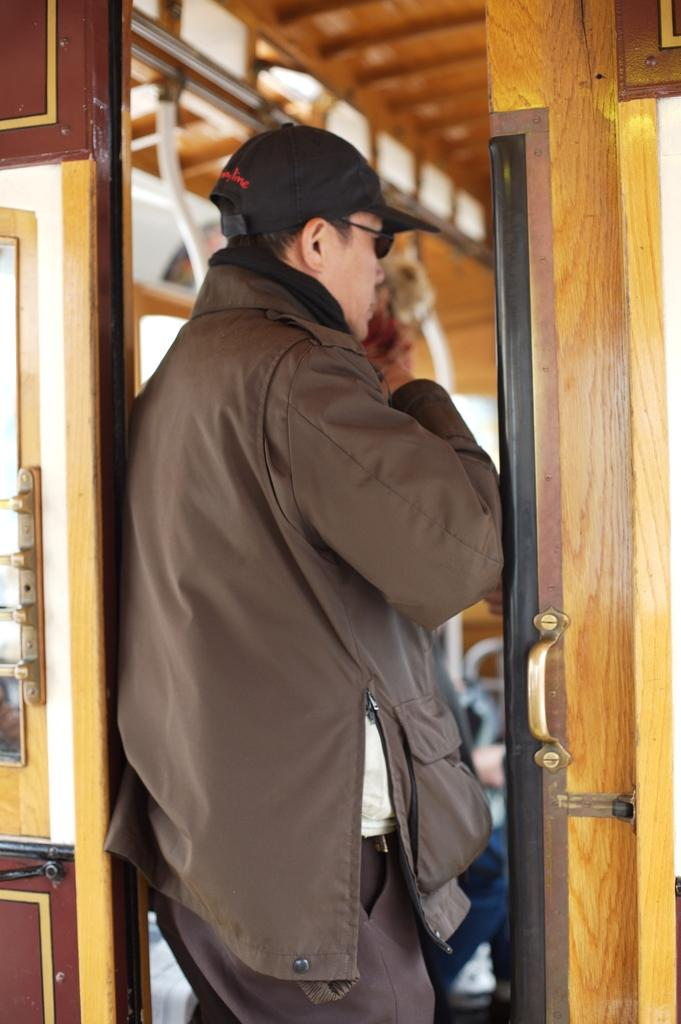What can be seen in the image related to a person? There is a person in the image. What protective gear is the person wearing? The person is wearing goggles. What type of headwear is the person wearing? The person is wearing a cap. What feature of the door is visible in the image? There is a door with a handle in the image. How would you describe the background of the image? The background of the image is blurry. What type of crate is being used for the fight in the image? There is no crate or fight present in the image. How many orders can be seen being placed in the image? There are no orders visible in the image. 